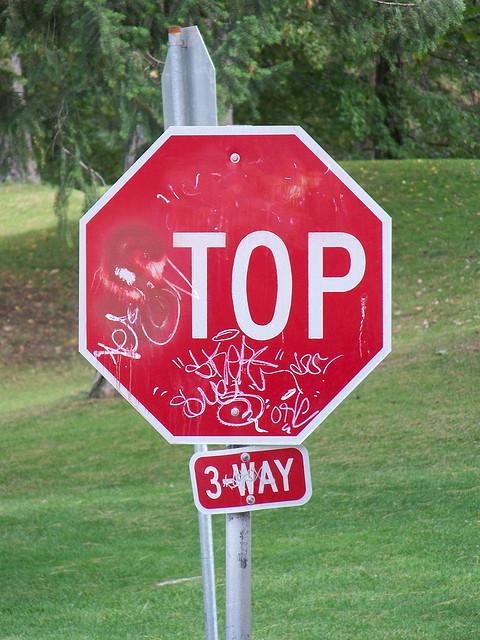Is this sign covered in graffiti?
Give a very brief answer. Yes. Is this a 3-way stop?
Write a very short answer. Yes. What does the sign say?
Answer briefly. Stop. 